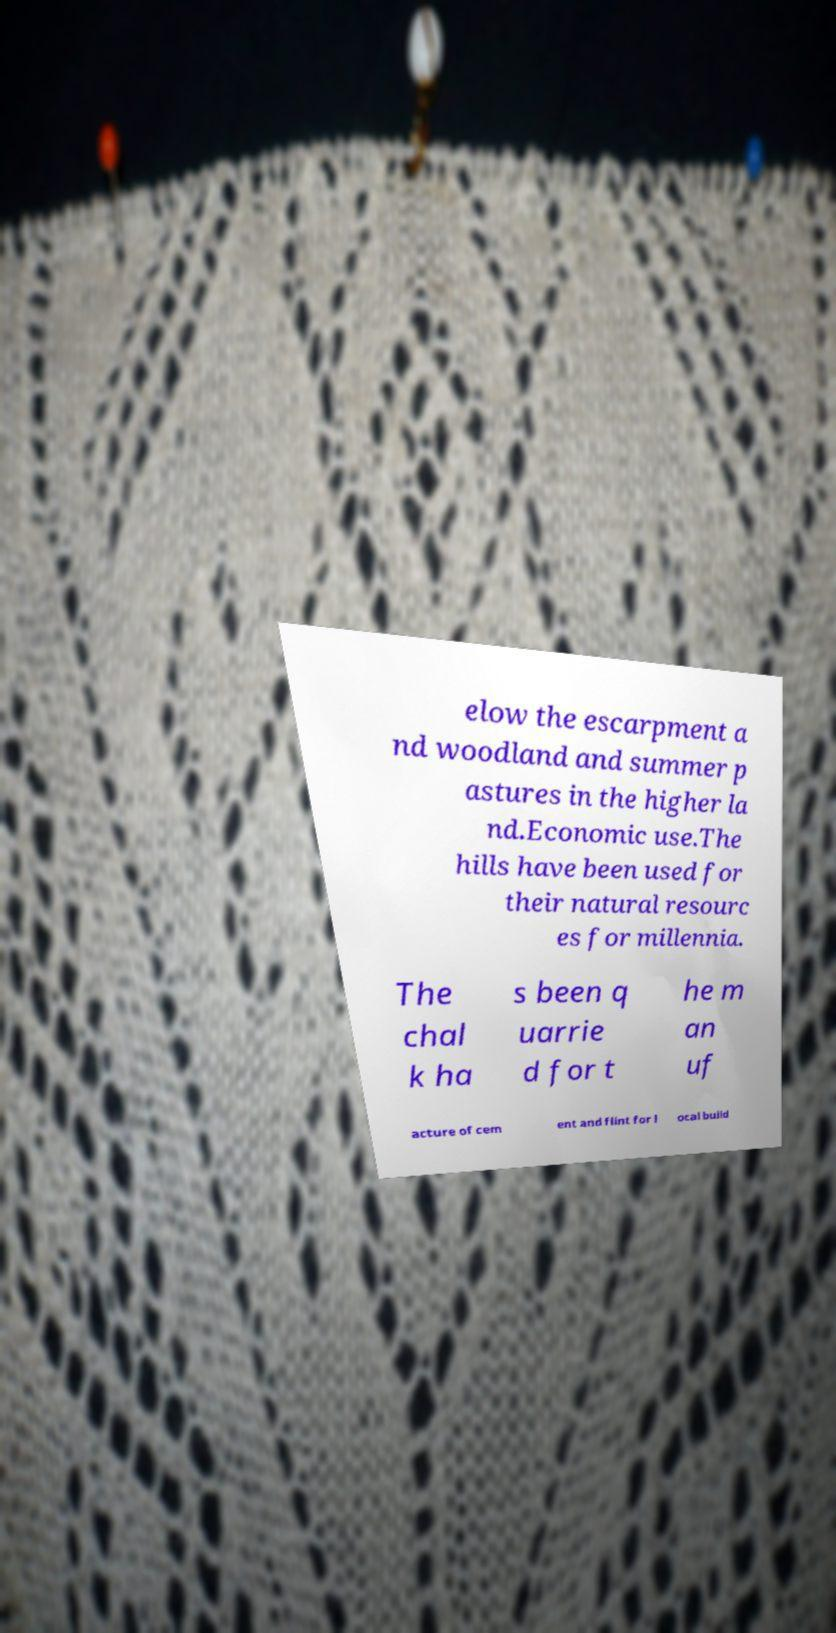Can you read and provide the text displayed in the image?This photo seems to have some interesting text. Can you extract and type it out for me? elow the escarpment a nd woodland and summer p astures in the higher la nd.Economic use.The hills have been used for their natural resourc es for millennia. The chal k ha s been q uarrie d for t he m an uf acture of cem ent and flint for l ocal build 